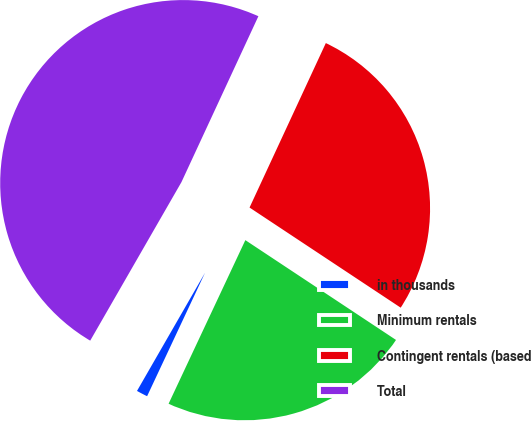Convert chart to OTSL. <chart><loc_0><loc_0><loc_500><loc_500><pie_chart><fcel>in thousands<fcel>Minimum rentals<fcel>Contingent rentals (based<fcel>Total<nl><fcel>1.33%<fcel>22.67%<fcel>27.4%<fcel>48.6%<nl></chart> 